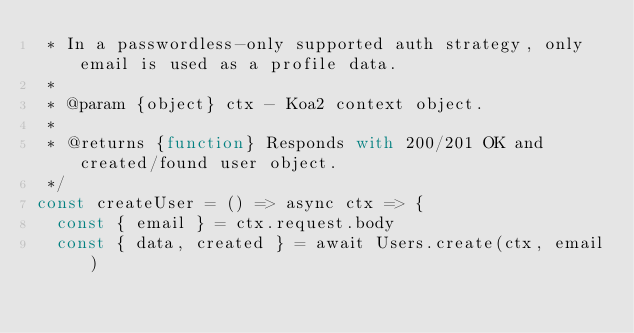Convert code to text. <code><loc_0><loc_0><loc_500><loc_500><_JavaScript_> * In a passwordless-only supported auth strategy, only email is used as a profile data.
 *
 * @param {object} ctx - Koa2 context object.
 *
 * @returns {function} Responds with 200/201 OK and created/found user object.
 */
const createUser = () => async ctx => {
  const { email } = ctx.request.body
  const { data, created } = await Users.create(ctx, email)</code> 